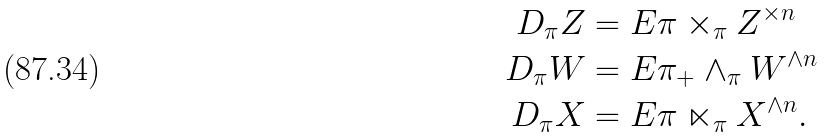Convert formula to latex. <formula><loc_0><loc_0><loc_500><loc_500>D _ { \pi } Z & = E \pi \times _ { \pi } Z ^ { \times n } \\ D _ { \pi } W & = E \pi _ { + } \wedge _ { \pi } W ^ { \wedge n } \\ D _ { \pi } X & = E \pi \ltimes _ { \pi } X ^ { \wedge n } .</formula> 